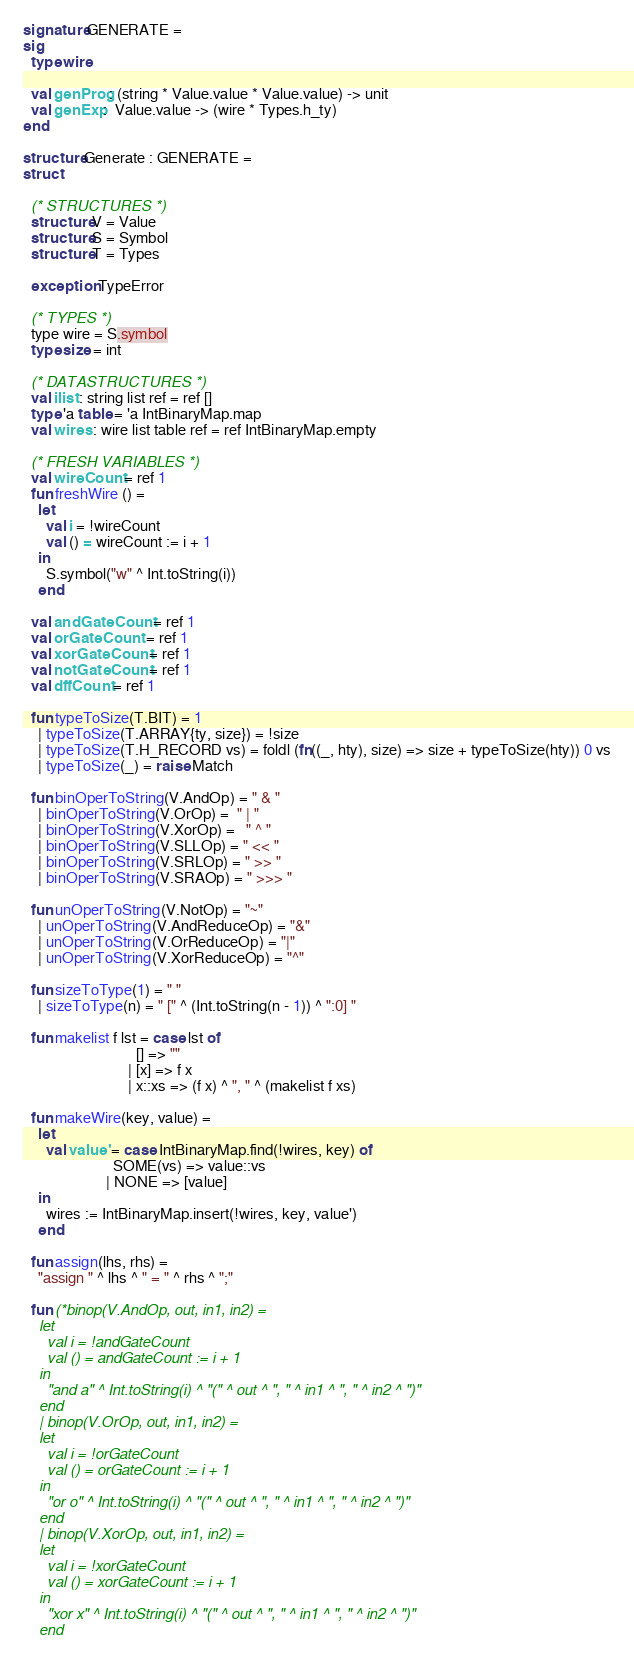<code> <loc_0><loc_0><loc_500><loc_500><_SML_>signature GENERATE = 
sig
  type wire

  val genProg: (string * Value.value * Value.value) -> unit
  val genExp:  Value.value -> (wire * Types.h_ty)
end

structure Generate : GENERATE = 
struct

  (* STRUCTURES *)
  structure V = Value
  structure S = Symbol
  structure T = Types

  exception TypeError

  (* TYPES *)
  type wire = S.symbol
  type size = int

  (* DATASTRUCTURES *)
  val ilist : string list ref = ref []
  type 'a table = 'a IntBinaryMap.map
  val wires : wire list table ref = ref IntBinaryMap.empty

  (* FRESH VARIABLES *)
  val wireCount = ref 1
  fun freshWire () =
    let
      val i = !wireCount
      val () = wireCount := i + 1
    in
      S.symbol("w" ^ Int.toString(i))
    end

  val andGateCount = ref 1
  val orGateCount  = ref 1
  val xorGateCount = ref 1 
  val notGateCount = ref 1
  val dffCount = ref 1

  fun typeToSize(T.BIT) = 1
    | typeToSize(T.ARRAY{ty, size}) = !size
    | typeToSize(T.H_RECORD vs) = foldl (fn((_, hty), size) => size + typeToSize(hty)) 0 vs
    | typeToSize(_) = raise Match

  fun binOperToString(V.AndOp) = " & "
    | binOperToString(V.OrOp) =  " | "
    | binOperToString(V.XorOp) =   " ^ "
    | binOperToString(V.SLLOp) = " << "
    | binOperToString(V.SRLOp) = " >> "
    | binOperToString(V.SRAOp) = " >>> "

  fun unOperToString(V.NotOp) = "~"
    | unOperToString(V.AndReduceOp) = "&"
    | unOperToString(V.OrReduceOp) = "|"
    | unOperToString(V.XorReduceOp) = "^"

  fun sizeToType(1) = " "
    | sizeToType(n) = " [" ^ (Int.toString(n - 1)) ^ ":0] "

  fun makelist f lst = case lst of 
                              [] => ""
                            | [x] => f x
                            | x::xs => (f x) ^ ", " ^ (makelist f xs)

  fun makeWire(key, value) =
    let
      val value' = case IntBinaryMap.find(!wires, key) of
                        SOME(vs) => value::vs
                      | NONE => [value]
    in
      wires := IntBinaryMap.insert(!wires, key, value')
    end

  fun assign(lhs, rhs) =
    "assign " ^ lhs ^ " = " ^ rhs ^ ";"

  fun (*binop(V.AndOp, out, in1, in2) =
    let
      val i = !andGateCount
      val () = andGateCount := i + 1
    in
      "and a" ^ Int.toString(i) ^ "(" ^ out ^ ", " ^ in1 ^ ", " ^ in2 ^ ")"
    end
    | binop(V.OrOp, out, in1, in2) =
    let
      val i = !orGateCount
      val () = orGateCount := i + 1
    in
      "or o" ^ Int.toString(i) ^ "(" ^ out ^ ", " ^ in1 ^ ", " ^ in2 ^ ")"
    end
    | binop(V.XorOp, out, in1, in2) =
    let
      val i = !xorGateCount
      val () = xorGateCount := i + 1
    in
      "xor x" ^ Int.toString(i) ^ "(" ^ out ^ ", " ^ in1 ^ ", " ^ in2 ^ ")"
    end</code> 